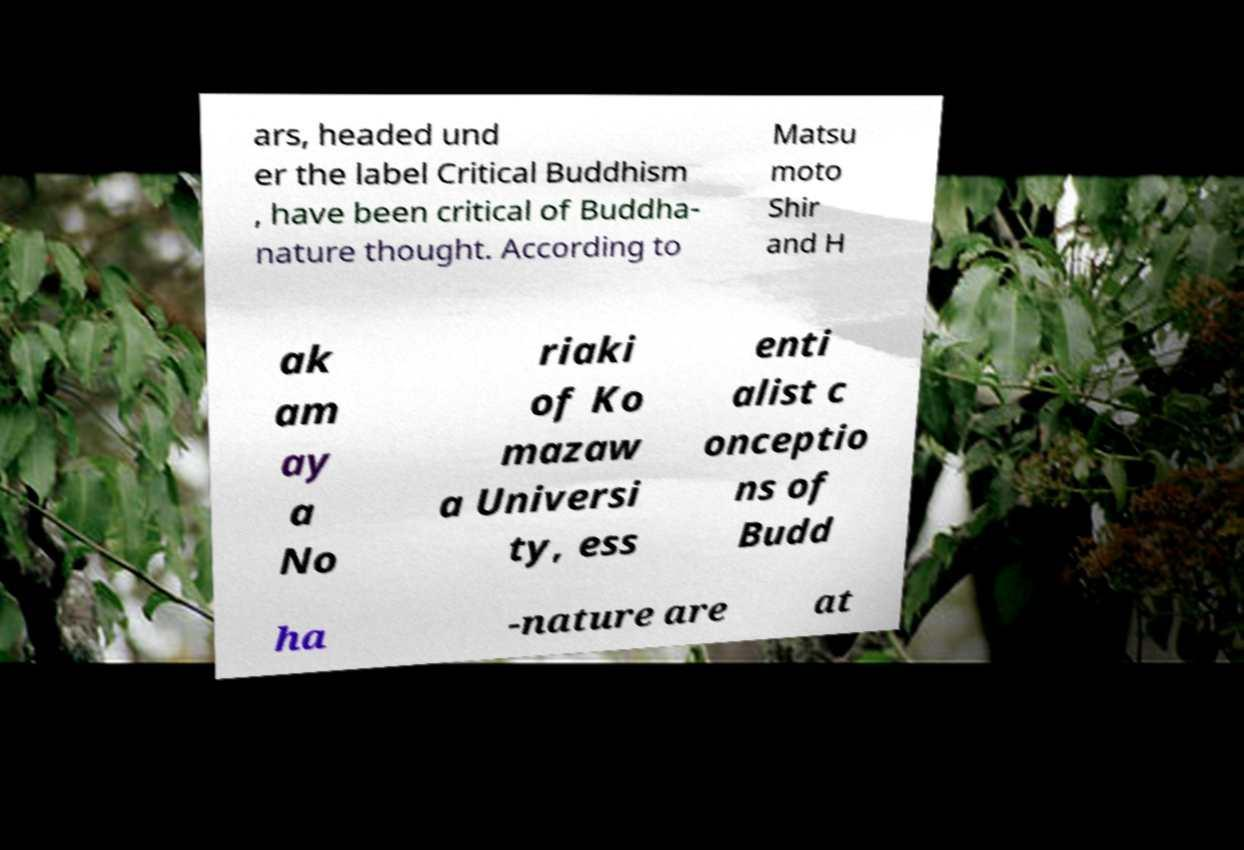For documentation purposes, I need the text within this image transcribed. Could you provide that? ars, headed und er the label Critical Buddhism , have been critical of Buddha- nature thought. According to Matsu moto Shir and H ak am ay a No riaki of Ko mazaw a Universi ty, ess enti alist c onceptio ns of Budd ha -nature are at 